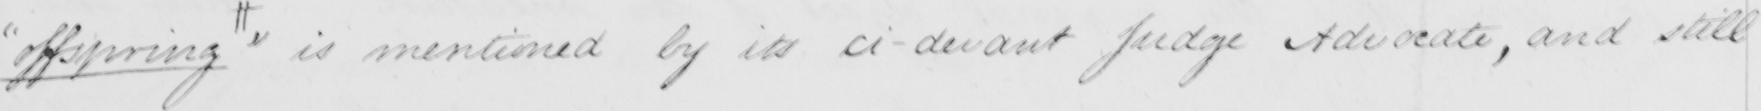Can you tell me what this handwritten text says? " offspring "  # is mentioned by its ci-devant Judge Advocate , and still 